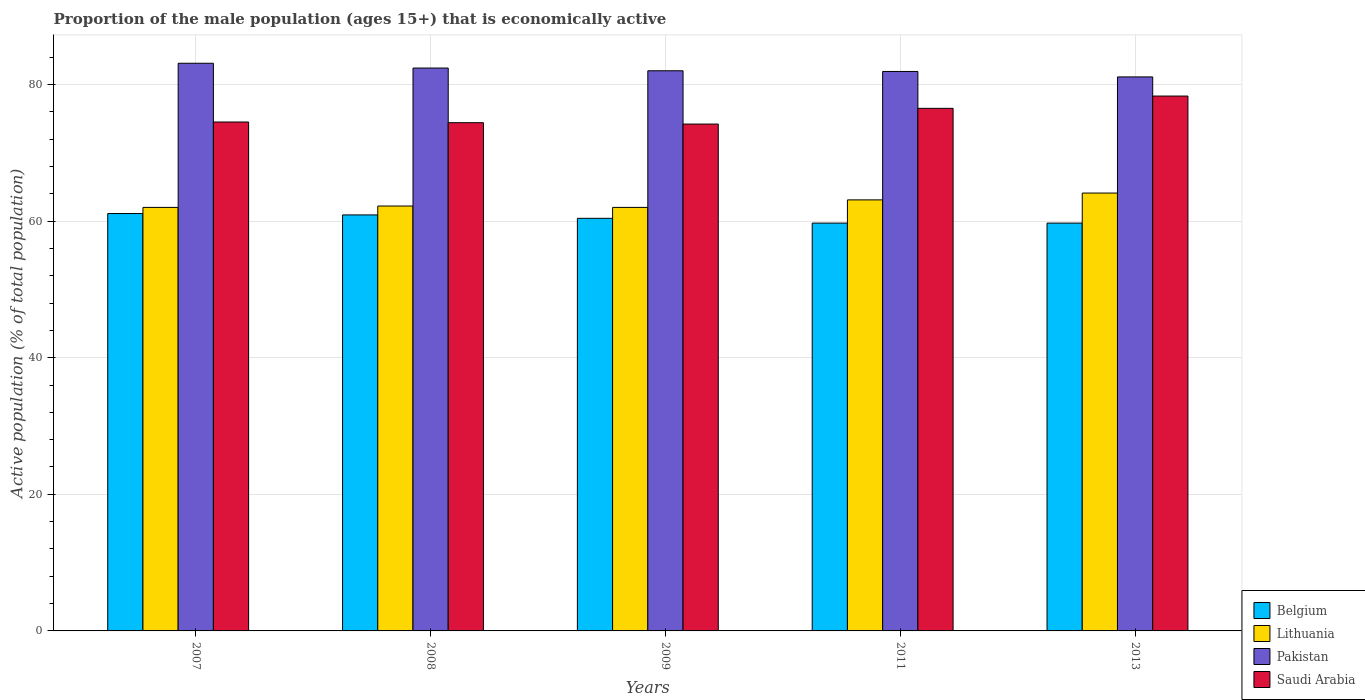How many different coloured bars are there?
Make the answer very short. 4. Are the number of bars on each tick of the X-axis equal?
Keep it short and to the point. Yes. How many bars are there on the 2nd tick from the right?
Your response must be concise. 4. What is the label of the 3rd group of bars from the left?
Provide a succinct answer. 2009. In how many cases, is the number of bars for a given year not equal to the number of legend labels?
Provide a succinct answer. 0. What is the proportion of the male population that is economically active in Belgium in 2011?
Offer a very short reply. 59.7. Across all years, what is the maximum proportion of the male population that is economically active in Belgium?
Provide a short and direct response. 61.1. Across all years, what is the minimum proportion of the male population that is economically active in Saudi Arabia?
Your answer should be compact. 74.2. What is the total proportion of the male population that is economically active in Belgium in the graph?
Offer a terse response. 301.8. What is the difference between the proportion of the male population that is economically active in Lithuania in 2008 and that in 2011?
Your answer should be very brief. -0.9. What is the difference between the proportion of the male population that is economically active in Saudi Arabia in 2011 and the proportion of the male population that is economically active in Pakistan in 2013?
Give a very brief answer. -4.6. What is the average proportion of the male population that is economically active in Lithuania per year?
Keep it short and to the point. 62.68. In the year 2009, what is the difference between the proportion of the male population that is economically active in Pakistan and proportion of the male population that is economically active in Saudi Arabia?
Provide a short and direct response. 7.8. What is the ratio of the proportion of the male population that is economically active in Lithuania in 2009 to that in 2011?
Keep it short and to the point. 0.98. Is the difference between the proportion of the male population that is economically active in Pakistan in 2007 and 2011 greater than the difference between the proportion of the male population that is economically active in Saudi Arabia in 2007 and 2011?
Provide a short and direct response. Yes. What is the difference between the highest and the second highest proportion of the male population that is economically active in Saudi Arabia?
Offer a very short reply. 1.8. What is the difference between the highest and the lowest proportion of the male population that is economically active in Pakistan?
Ensure brevity in your answer.  2. What does the 2nd bar from the left in 2007 represents?
Offer a terse response. Lithuania. What does the 1st bar from the right in 2013 represents?
Your answer should be very brief. Saudi Arabia. How many bars are there?
Give a very brief answer. 20. What is the difference between two consecutive major ticks on the Y-axis?
Offer a very short reply. 20. Does the graph contain any zero values?
Your response must be concise. No. How are the legend labels stacked?
Your answer should be very brief. Vertical. What is the title of the graph?
Keep it short and to the point. Proportion of the male population (ages 15+) that is economically active. Does "Paraguay" appear as one of the legend labels in the graph?
Make the answer very short. No. What is the label or title of the Y-axis?
Your answer should be very brief. Active population (% of total population). What is the Active population (% of total population) in Belgium in 2007?
Make the answer very short. 61.1. What is the Active population (% of total population) of Pakistan in 2007?
Your answer should be compact. 83.1. What is the Active population (% of total population) of Saudi Arabia in 2007?
Make the answer very short. 74.5. What is the Active population (% of total population) of Belgium in 2008?
Your answer should be compact. 60.9. What is the Active population (% of total population) in Lithuania in 2008?
Your answer should be compact. 62.2. What is the Active population (% of total population) in Pakistan in 2008?
Make the answer very short. 82.4. What is the Active population (% of total population) in Saudi Arabia in 2008?
Provide a short and direct response. 74.4. What is the Active population (% of total population) in Belgium in 2009?
Provide a short and direct response. 60.4. What is the Active population (% of total population) in Pakistan in 2009?
Your response must be concise. 82. What is the Active population (% of total population) of Saudi Arabia in 2009?
Provide a short and direct response. 74.2. What is the Active population (% of total population) in Belgium in 2011?
Offer a terse response. 59.7. What is the Active population (% of total population) of Lithuania in 2011?
Give a very brief answer. 63.1. What is the Active population (% of total population) of Pakistan in 2011?
Provide a short and direct response. 81.9. What is the Active population (% of total population) of Saudi Arabia in 2011?
Provide a short and direct response. 76.5. What is the Active population (% of total population) of Belgium in 2013?
Offer a very short reply. 59.7. What is the Active population (% of total population) in Lithuania in 2013?
Ensure brevity in your answer.  64.1. What is the Active population (% of total population) in Pakistan in 2013?
Your response must be concise. 81.1. What is the Active population (% of total population) of Saudi Arabia in 2013?
Ensure brevity in your answer.  78.3. Across all years, what is the maximum Active population (% of total population) in Belgium?
Keep it short and to the point. 61.1. Across all years, what is the maximum Active population (% of total population) of Lithuania?
Give a very brief answer. 64.1. Across all years, what is the maximum Active population (% of total population) in Pakistan?
Your answer should be very brief. 83.1. Across all years, what is the maximum Active population (% of total population) of Saudi Arabia?
Your response must be concise. 78.3. Across all years, what is the minimum Active population (% of total population) of Belgium?
Make the answer very short. 59.7. Across all years, what is the minimum Active population (% of total population) of Pakistan?
Offer a terse response. 81.1. Across all years, what is the minimum Active population (% of total population) of Saudi Arabia?
Give a very brief answer. 74.2. What is the total Active population (% of total population) in Belgium in the graph?
Make the answer very short. 301.8. What is the total Active population (% of total population) of Lithuania in the graph?
Make the answer very short. 313.4. What is the total Active population (% of total population) in Pakistan in the graph?
Give a very brief answer. 410.5. What is the total Active population (% of total population) in Saudi Arabia in the graph?
Your response must be concise. 377.9. What is the difference between the Active population (% of total population) in Belgium in 2007 and that in 2008?
Ensure brevity in your answer.  0.2. What is the difference between the Active population (% of total population) in Lithuania in 2007 and that in 2008?
Your answer should be very brief. -0.2. What is the difference between the Active population (% of total population) in Saudi Arabia in 2007 and that in 2008?
Offer a terse response. 0.1. What is the difference between the Active population (% of total population) in Lithuania in 2007 and that in 2009?
Give a very brief answer. 0. What is the difference between the Active population (% of total population) of Saudi Arabia in 2007 and that in 2009?
Give a very brief answer. 0.3. What is the difference between the Active population (% of total population) of Belgium in 2007 and that in 2011?
Ensure brevity in your answer.  1.4. What is the difference between the Active population (% of total population) in Lithuania in 2007 and that in 2011?
Give a very brief answer. -1.1. What is the difference between the Active population (% of total population) of Pakistan in 2007 and that in 2011?
Make the answer very short. 1.2. What is the difference between the Active population (% of total population) of Belgium in 2007 and that in 2013?
Give a very brief answer. 1.4. What is the difference between the Active population (% of total population) of Pakistan in 2007 and that in 2013?
Keep it short and to the point. 2. What is the difference between the Active population (% of total population) in Pakistan in 2008 and that in 2009?
Offer a very short reply. 0.4. What is the difference between the Active population (% of total population) in Belgium in 2008 and that in 2011?
Your answer should be very brief. 1.2. What is the difference between the Active population (% of total population) in Pakistan in 2008 and that in 2011?
Your answer should be very brief. 0.5. What is the difference between the Active population (% of total population) of Saudi Arabia in 2008 and that in 2011?
Provide a short and direct response. -2.1. What is the difference between the Active population (% of total population) in Belgium in 2008 and that in 2013?
Your answer should be compact. 1.2. What is the difference between the Active population (% of total population) in Lithuania in 2008 and that in 2013?
Your response must be concise. -1.9. What is the difference between the Active population (% of total population) of Saudi Arabia in 2008 and that in 2013?
Offer a very short reply. -3.9. What is the difference between the Active population (% of total population) in Lithuania in 2009 and that in 2011?
Offer a very short reply. -1.1. What is the difference between the Active population (% of total population) in Pakistan in 2009 and that in 2011?
Keep it short and to the point. 0.1. What is the difference between the Active population (% of total population) of Lithuania in 2009 and that in 2013?
Offer a terse response. -2.1. What is the difference between the Active population (% of total population) in Pakistan in 2009 and that in 2013?
Provide a short and direct response. 0.9. What is the difference between the Active population (% of total population) of Saudi Arabia in 2009 and that in 2013?
Give a very brief answer. -4.1. What is the difference between the Active population (% of total population) in Belgium in 2007 and the Active population (% of total population) in Pakistan in 2008?
Your answer should be very brief. -21.3. What is the difference between the Active population (% of total population) in Lithuania in 2007 and the Active population (% of total population) in Pakistan in 2008?
Offer a very short reply. -20.4. What is the difference between the Active population (% of total population) in Belgium in 2007 and the Active population (% of total population) in Lithuania in 2009?
Your answer should be compact. -0.9. What is the difference between the Active population (% of total population) in Belgium in 2007 and the Active population (% of total population) in Pakistan in 2009?
Offer a very short reply. -20.9. What is the difference between the Active population (% of total population) in Belgium in 2007 and the Active population (% of total population) in Saudi Arabia in 2009?
Make the answer very short. -13.1. What is the difference between the Active population (% of total population) of Lithuania in 2007 and the Active population (% of total population) of Pakistan in 2009?
Give a very brief answer. -20. What is the difference between the Active population (% of total population) of Lithuania in 2007 and the Active population (% of total population) of Saudi Arabia in 2009?
Your response must be concise. -12.2. What is the difference between the Active population (% of total population) in Pakistan in 2007 and the Active population (% of total population) in Saudi Arabia in 2009?
Provide a short and direct response. 8.9. What is the difference between the Active population (% of total population) of Belgium in 2007 and the Active population (% of total population) of Pakistan in 2011?
Your answer should be very brief. -20.8. What is the difference between the Active population (% of total population) in Belgium in 2007 and the Active population (% of total population) in Saudi Arabia in 2011?
Provide a succinct answer. -15.4. What is the difference between the Active population (% of total population) in Lithuania in 2007 and the Active population (% of total population) in Pakistan in 2011?
Ensure brevity in your answer.  -19.9. What is the difference between the Active population (% of total population) in Lithuania in 2007 and the Active population (% of total population) in Saudi Arabia in 2011?
Your answer should be very brief. -14.5. What is the difference between the Active population (% of total population) in Pakistan in 2007 and the Active population (% of total population) in Saudi Arabia in 2011?
Offer a very short reply. 6.6. What is the difference between the Active population (% of total population) of Belgium in 2007 and the Active population (% of total population) of Lithuania in 2013?
Offer a terse response. -3. What is the difference between the Active population (% of total population) of Belgium in 2007 and the Active population (% of total population) of Saudi Arabia in 2013?
Your answer should be very brief. -17.2. What is the difference between the Active population (% of total population) of Lithuania in 2007 and the Active population (% of total population) of Pakistan in 2013?
Give a very brief answer. -19.1. What is the difference between the Active population (% of total population) in Lithuania in 2007 and the Active population (% of total population) in Saudi Arabia in 2013?
Offer a very short reply. -16.3. What is the difference between the Active population (% of total population) in Belgium in 2008 and the Active population (% of total population) in Pakistan in 2009?
Your response must be concise. -21.1. What is the difference between the Active population (% of total population) of Belgium in 2008 and the Active population (% of total population) of Saudi Arabia in 2009?
Your answer should be very brief. -13.3. What is the difference between the Active population (% of total population) of Lithuania in 2008 and the Active population (% of total population) of Pakistan in 2009?
Make the answer very short. -19.8. What is the difference between the Active population (% of total population) in Lithuania in 2008 and the Active population (% of total population) in Saudi Arabia in 2009?
Your response must be concise. -12. What is the difference between the Active population (% of total population) in Pakistan in 2008 and the Active population (% of total population) in Saudi Arabia in 2009?
Make the answer very short. 8.2. What is the difference between the Active population (% of total population) in Belgium in 2008 and the Active population (% of total population) in Saudi Arabia in 2011?
Provide a succinct answer. -15.6. What is the difference between the Active population (% of total population) of Lithuania in 2008 and the Active population (% of total population) of Pakistan in 2011?
Offer a terse response. -19.7. What is the difference between the Active population (% of total population) in Lithuania in 2008 and the Active population (% of total population) in Saudi Arabia in 2011?
Provide a short and direct response. -14.3. What is the difference between the Active population (% of total population) of Belgium in 2008 and the Active population (% of total population) of Pakistan in 2013?
Make the answer very short. -20.2. What is the difference between the Active population (% of total population) of Belgium in 2008 and the Active population (% of total population) of Saudi Arabia in 2013?
Your answer should be very brief. -17.4. What is the difference between the Active population (% of total population) in Lithuania in 2008 and the Active population (% of total population) in Pakistan in 2013?
Ensure brevity in your answer.  -18.9. What is the difference between the Active population (% of total population) in Lithuania in 2008 and the Active population (% of total population) in Saudi Arabia in 2013?
Make the answer very short. -16.1. What is the difference between the Active population (% of total population) of Pakistan in 2008 and the Active population (% of total population) of Saudi Arabia in 2013?
Your answer should be compact. 4.1. What is the difference between the Active population (% of total population) of Belgium in 2009 and the Active population (% of total population) of Pakistan in 2011?
Keep it short and to the point. -21.5. What is the difference between the Active population (% of total population) of Belgium in 2009 and the Active population (% of total population) of Saudi Arabia in 2011?
Your answer should be compact. -16.1. What is the difference between the Active population (% of total population) of Lithuania in 2009 and the Active population (% of total population) of Pakistan in 2011?
Ensure brevity in your answer.  -19.9. What is the difference between the Active population (% of total population) in Lithuania in 2009 and the Active population (% of total population) in Saudi Arabia in 2011?
Make the answer very short. -14.5. What is the difference between the Active population (% of total population) of Belgium in 2009 and the Active population (% of total population) of Lithuania in 2013?
Your response must be concise. -3.7. What is the difference between the Active population (% of total population) in Belgium in 2009 and the Active population (% of total population) in Pakistan in 2013?
Provide a succinct answer. -20.7. What is the difference between the Active population (% of total population) in Belgium in 2009 and the Active population (% of total population) in Saudi Arabia in 2013?
Keep it short and to the point. -17.9. What is the difference between the Active population (% of total population) in Lithuania in 2009 and the Active population (% of total population) in Pakistan in 2013?
Your answer should be compact. -19.1. What is the difference between the Active population (% of total population) of Lithuania in 2009 and the Active population (% of total population) of Saudi Arabia in 2013?
Keep it short and to the point. -16.3. What is the difference between the Active population (% of total population) in Pakistan in 2009 and the Active population (% of total population) in Saudi Arabia in 2013?
Give a very brief answer. 3.7. What is the difference between the Active population (% of total population) in Belgium in 2011 and the Active population (% of total population) in Pakistan in 2013?
Give a very brief answer. -21.4. What is the difference between the Active population (% of total population) in Belgium in 2011 and the Active population (% of total population) in Saudi Arabia in 2013?
Your answer should be very brief. -18.6. What is the difference between the Active population (% of total population) in Lithuania in 2011 and the Active population (% of total population) in Saudi Arabia in 2013?
Offer a very short reply. -15.2. What is the average Active population (% of total population) in Belgium per year?
Keep it short and to the point. 60.36. What is the average Active population (% of total population) of Lithuania per year?
Your answer should be compact. 62.68. What is the average Active population (% of total population) of Pakistan per year?
Give a very brief answer. 82.1. What is the average Active population (% of total population) in Saudi Arabia per year?
Offer a very short reply. 75.58. In the year 2007, what is the difference between the Active population (% of total population) of Belgium and Active population (% of total population) of Lithuania?
Provide a succinct answer. -0.9. In the year 2007, what is the difference between the Active population (% of total population) in Belgium and Active population (% of total population) in Pakistan?
Give a very brief answer. -22. In the year 2007, what is the difference between the Active population (% of total population) in Belgium and Active population (% of total population) in Saudi Arabia?
Keep it short and to the point. -13.4. In the year 2007, what is the difference between the Active population (% of total population) in Lithuania and Active population (% of total population) in Pakistan?
Make the answer very short. -21.1. In the year 2007, what is the difference between the Active population (% of total population) in Pakistan and Active population (% of total population) in Saudi Arabia?
Your answer should be compact. 8.6. In the year 2008, what is the difference between the Active population (% of total population) in Belgium and Active population (% of total population) in Lithuania?
Your answer should be very brief. -1.3. In the year 2008, what is the difference between the Active population (% of total population) in Belgium and Active population (% of total population) in Pakistan?
Offer a very short reply. -21.5. In the year 2008, what is the difference between the Active population (% of total population) of Lithuania and Active population (% of total population) of Pakistan?
Your response must be concise. -20.2. In the year 2009, what is the difference between the Active population (% of total population) of Belgium and Active population (% of total population) of Lithuania?
Your response must be concise. -1.6. In the year 2009, what is the difference between the Active population (% of total population) of Belgium and Active population (% of total population) of Pakistan?
Provide a short and direct response. -21.6. In the year 2011, what is the difference between the Active population (% of total population) of Belgium and Active population (% of total population) of Pakistan?
Give a very brief answer. -22.2. In the year 2011, what is the difference between the Active population (% of total population) of Belgium and Active population (% of total population) of Saudi Arabia?
Offer a terse response. -16.8. In the year 2011, what is the difference between the Active population (% of total population) of Lithuania and Active population (% of total population) of Pakistan?
Give a very brief answer. -18.8. In the year 2013, what is the difference between the Active population (% of total population) of Belgium and Active population (% of total population) of Lithuania?
Provide a succinct answer. -4.4. In the year 2013, what is the difference between the Active population (% of total population) of Belgium and Active population (% of total population) of Pakistan?
Provide a short and direct response. -21.4. In the year 2013, what is the difference between the Active population (% of total population) of Belgium and Active population (% of total population) of Saudi Arabia?
Provide a succinct answer. -18.6. In the year 2013, what is the difference between the Active population (% of total population) in Lithuania and Active population (% of total population) in Pakistan?
Your answer should be very brief. -17. In the year 2013, what is the difference between the Active population (% of total population) in Lithuania and Active population (% of total population) in Saudi Arabia?
Your answer should be very brief. -14.2. In the year 2013, what is the difference between the Active population (% of total population) in Pakistan and Active population (% of total population) in Saudi Arabia?
Offer a very short reply. 2.8. What is the ratio of the Active population (% of total population) in Belgium in 2007 to that in 2008?
Your answer should be very brief. 1. What is the ratio of the Active population (% of total population) of Lithuania in 2007 to that in 2008?
Ensure brevity in your answer.  1. What is the ratio of the Active population (% of total population) in Pakistan in 2007 to that in 2008?
Your response must be concise. 1.01. What is the ratio of the Active population (% of total population) in Belgium in 2007 to that in 2009?
Offer a terse response. 1.01. What is the ratio of the Active population (% of total population) in Lithuania in 2007 to that in 2009?
Give a very brief answer. 1. What is the ratio of the Active population (% of total population) in Pakistan in 2007 to that in 2009?
Give a very brief answer. 1.01. What is the ratio of the Active population (% of total population) in Saudi Arabia in 2007 to that in 2009?
Your answer should be very brief. 1. What is the ratio of the Active population (% of total population) of Belgium in 2007 to that in 2011?
Give a very brief answer. 1.02. What is the ratio of the Active population (% of total population) in Lithuania in 2007 to that in 2011?
Your answer should be compact. 0.98. What is the ratio of the Active population (% of total population) in Pakistan in 2007 to that in 2011?
Provide a short and direct response. 1.01. What is the ratio of the Active population (% of total population) of Saudi Arabia in 2007 to that in 2011?
Ensure brevity in your answer.  0.97. What is the ratio of the Active population (% of total population) of Belgium in 2007 to that in 2013?
Your answer should be compact. 1.02. What is the ratio of the Active population (% of total population) in Lithuania in 2007 to that in 2013?
Offer a terse response. 0.97. What is the ratio of the Active population (% of total population) in Pakistan in 2007 to that in 2013?
Your answer should be compact. 1.02. What is the ratio of the Active population (% of total population) of Saudi Arabia in 2007 to that in 2013?
Give a very brief answer. 0.95. What is the ratio of the Active population (% of total population) of Belgium in 2008 to that in 2009?
Your response must be concise. 1.01. What is the ratio of the Active population (% of total population) of Belgium in 2008 to that in 2011?
Give a very brief answer. 1.02. What is the ratio of the Active population (% of total population) in Lithuania in 2008 to that in 2011?
Provide a short and direct response. 0.99. What is the ratio of the Active population (% of total population) in Saudi Arabia in 2008 to that in 2011?
Your response must be concise. 0.97. What is the ratio of the Active population (% of total population) of Belgium in 2008 to that in 2013?
Give a very brief answer. 1.02. What is the ratio of the Active population (% of total population) of Lithuania in 2008 to that in 2013?
Your answer should be compact. 0.97. What is the ratio of the Active population (% of total population) of Saudi Arabia in 2008 to that in 2013?
Provide a succinct answer. 0.95. What is the ratio of the Active population (% of total population) of Belgium in 2009 to that in 2011?
Offer a terse response. 1.01. What is the ratio of the Active population (% of total population) in Lithuania in 2009 to that in 2011?
Give a very brief answer. 0.98. What is the ratio of the Active population (% of total population) in Saudi Arabia in 2009 to that in 2011?
Keep it short and to the point. 0.97. What is the ratio of the Active population (% of total population) of Belgium in 2009 to that in 2013?
Offer a terse response. 1.01. What is the ratio of the Active population (% of total population) of Lithuania in 2009 to that in 2013?
Offer a very short reply. 0.97. What is the ratio of the Active population (% of total population) of Pakistan in 2009 to that in 2013?
Make the answer very short. 1.01. What is the ratio of the Active population (% of total population) of Saudi Arabia in 2009 to that in 2013?
Your answer should be very brief. 0.95. What is the ratio of the Active population (% of total population) of Belgium in 2011 to that in 2013?
Your answer should be very brief. 1. What is the ratio of the Active population (% of total population) of Lithuania in 2011 to that in 2013?
Your answer should be very brief. 0.98. What is the ratio of the Active population (% of total population) of Pakistan in 2011 to that in 2013?
Provide a short and direct response. 1.01. What is the difference between the highest and the second highest Active population (% of total population) of Belgium?
Ensure brevity in your answer.  0.2. What is the difference between the highest and the second highest Active population (% of total population) of Pakistan?
Provide a succinct answer. 0.7. What is the difference between the highest and the second highest Active population (% of total population) in Saudi Arabia?
Give a very brief answer. 1.8. What is the difference between the highest and the lowest Active population (% of total population) of Lithuania?
Keep it short and to the point. 2.1. What is the difference between the highest and the lowest Active population (% of total population) of Pakistan?
Keep it short and to the point. 2. What is the difference between the highest and the lowest Active population (% of total population) in Saudi Arabia?
Make the answer very short. 4.1. 